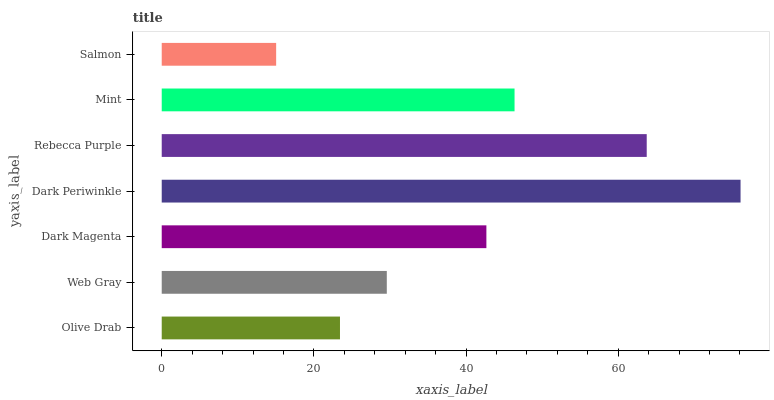Is Salmon the minimum?
Answer yes or no. Yes. Is Dark Periwinkle the maximum?
Answer yes or no. Yes. Is Web Gray the minimum?
Answer yes or no. No. Is Web Gray the maximum?
Answer yes or no. No. Is Web Gray greater than Olive Drab?
Answer yes or no. Yes. Is Olive Drab less than Web Gray?
Answer yes or no. Yes. Is Olive Drab greater than Web Gray?
Answer yes or no. No. Is Web Gray less than Olive Drab?
Answer yes or no. No. Is Dark Magenta the high median?
Answer yes or no. Yes. Is Dark Magenta the low median?
Answer yes or no. Yes. Is Web Gray the high median?
Answer yes or no. No. Is Mint the low median?
Answer yes or no. No. 